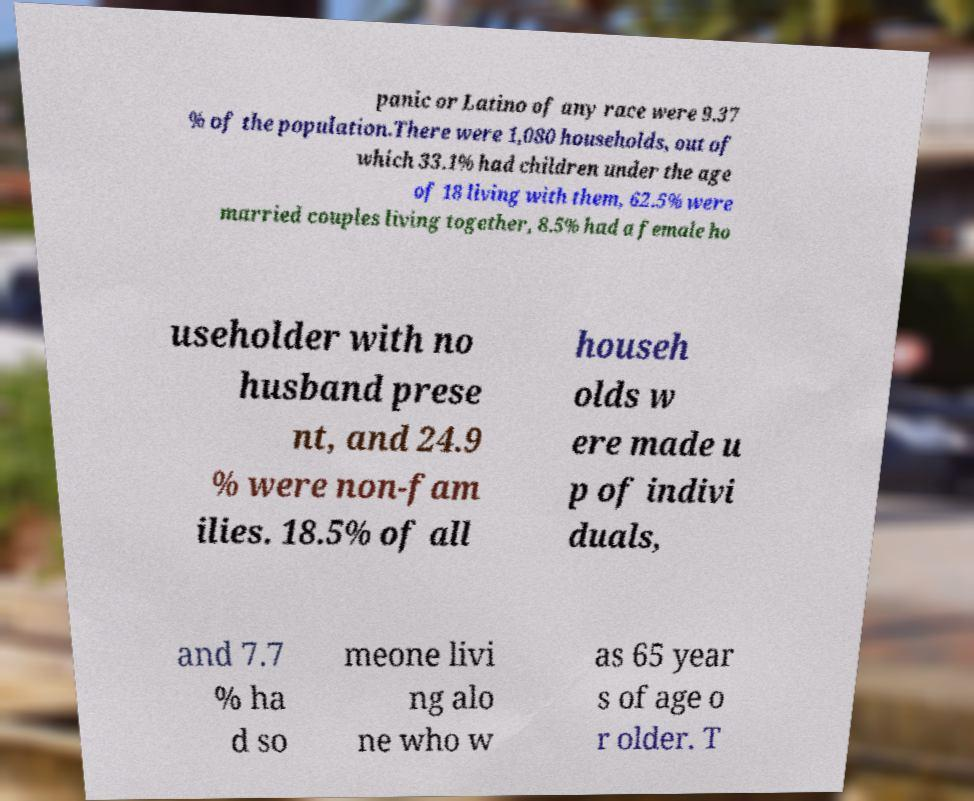Can you read and provide the text displayed in the image?This photo seems to have some interesting text. Can you extract and type it out for me? panic or Latino of any race were 9.37 % of the population.There were 1,080 households, out of which 33.1% had children under the age of 18 living with them, 62.5% were married couples living together, 8.5% had a female ho useholder with no husband prese nt, and 24.9 % were non-fam ilies. 18.5% of all househ olds w ere made u p of indivi duals, and 7.7 % ha d so meone livi ng alo ne who w as 65 year s of age o r older. T 